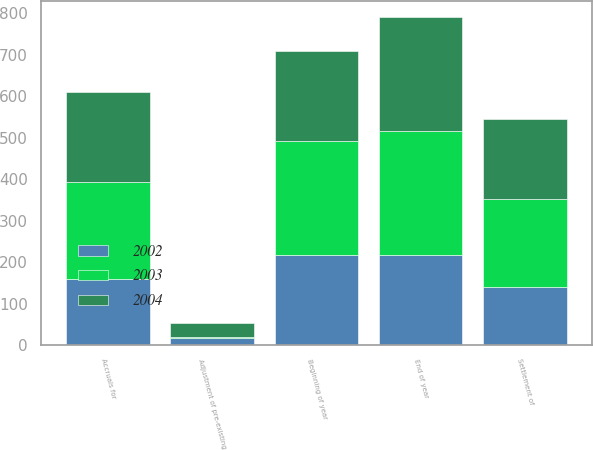Convert chart. <chart><loc_0><loc_0><loc_500><loc_500><stacked_bar_chart><ecel><fcel>Beginning of year<fcel>Accruals for<fcel>Adjustment of pre-existing<fcel>Settlement of<fcel>End of year<nl><fcel>2003<fcel>275<fcel>236<fcel>1<fcel>213<fcel>299<nl><fcel>2004<fcel>217<fcel>215<fcel>35<fcel>192<fcel>275<nl><fcel>2002<fcel>217<fcel>158<fcel>18<fcel>140<fcel>217<nl></chart> 